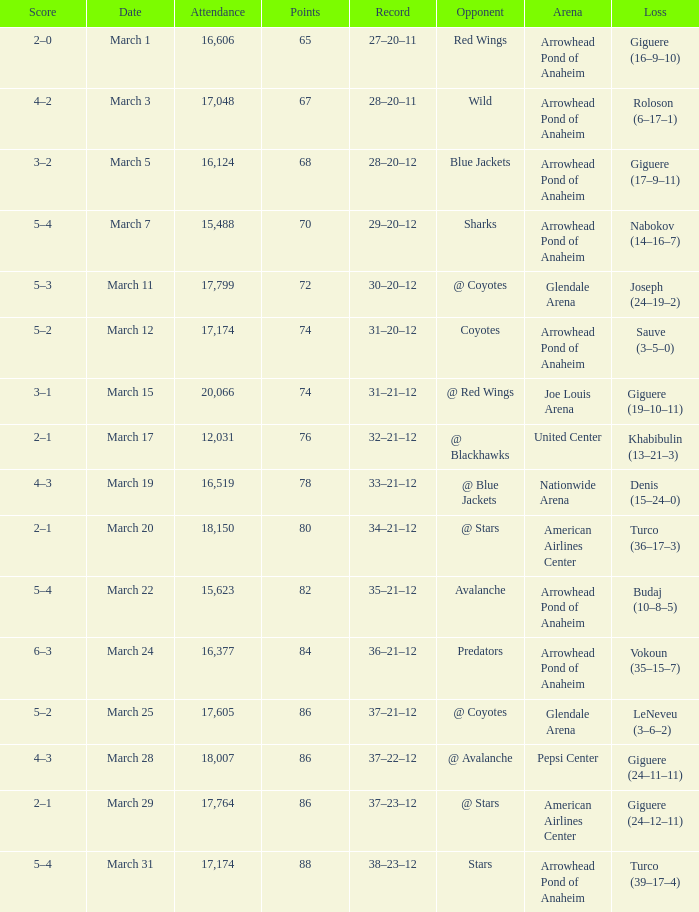What is the Attendance of the game with a Record of 37–21–12 and less than 86 Points? None. 